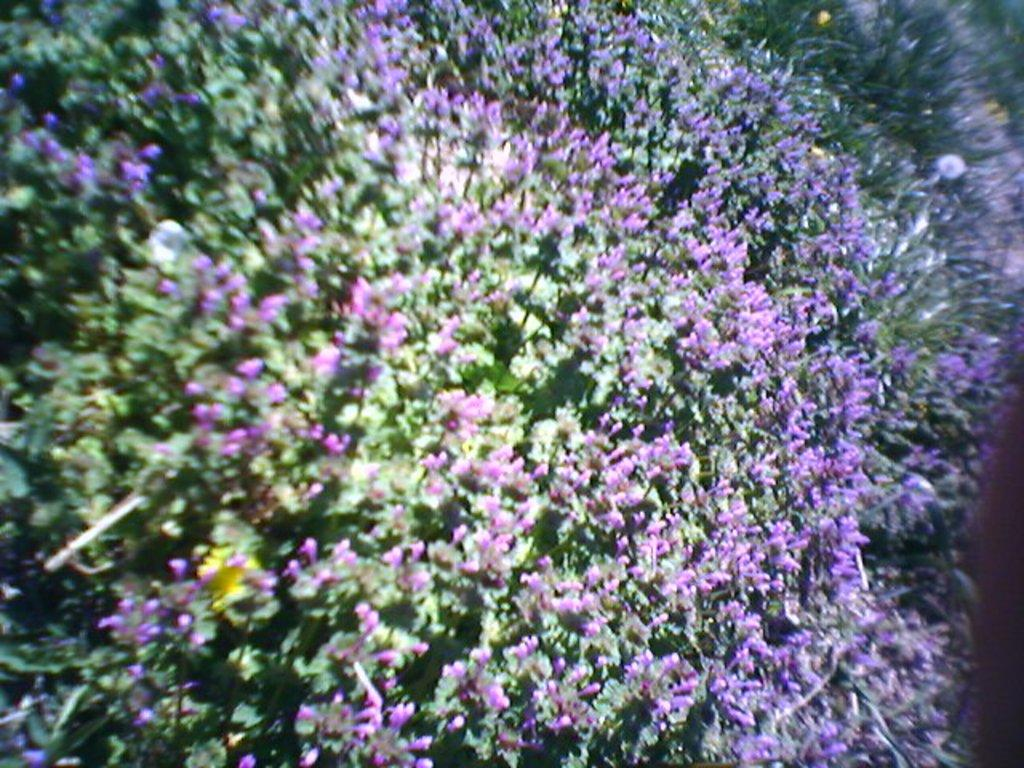What type of plants can be seen in the image? There are flower plants in the image. How many bananas are hanging from the flower plants in the image? There are no bananas present in the image; it only features flower plants. Can you describe the romantic interaction between the flower plants in the image? There is no romantic interaction depicted in the image, as it only features flower plants. 